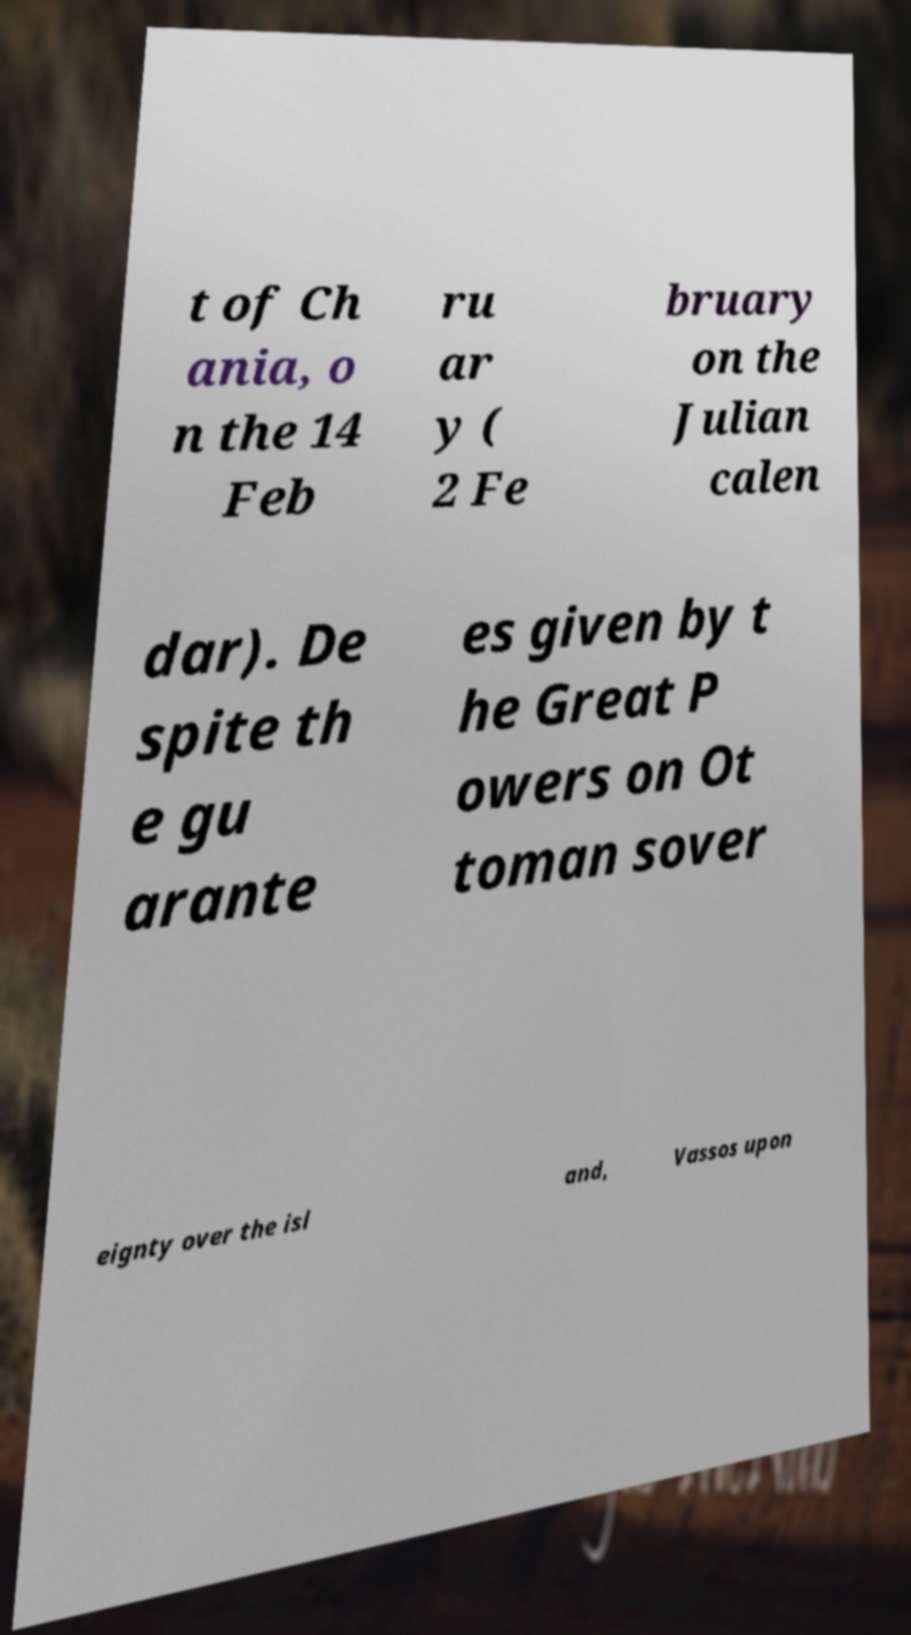What messages or text are displayed in this image? I need them in a readable, typed format. t of Ch ania, o n the 14 Feb ru ar y ( 2 Fe bruary on the Julian calen dar). De spite th e gu arante es given by t he Great P owers on Ot toman sover eignty over the isl and, Vassos upon 